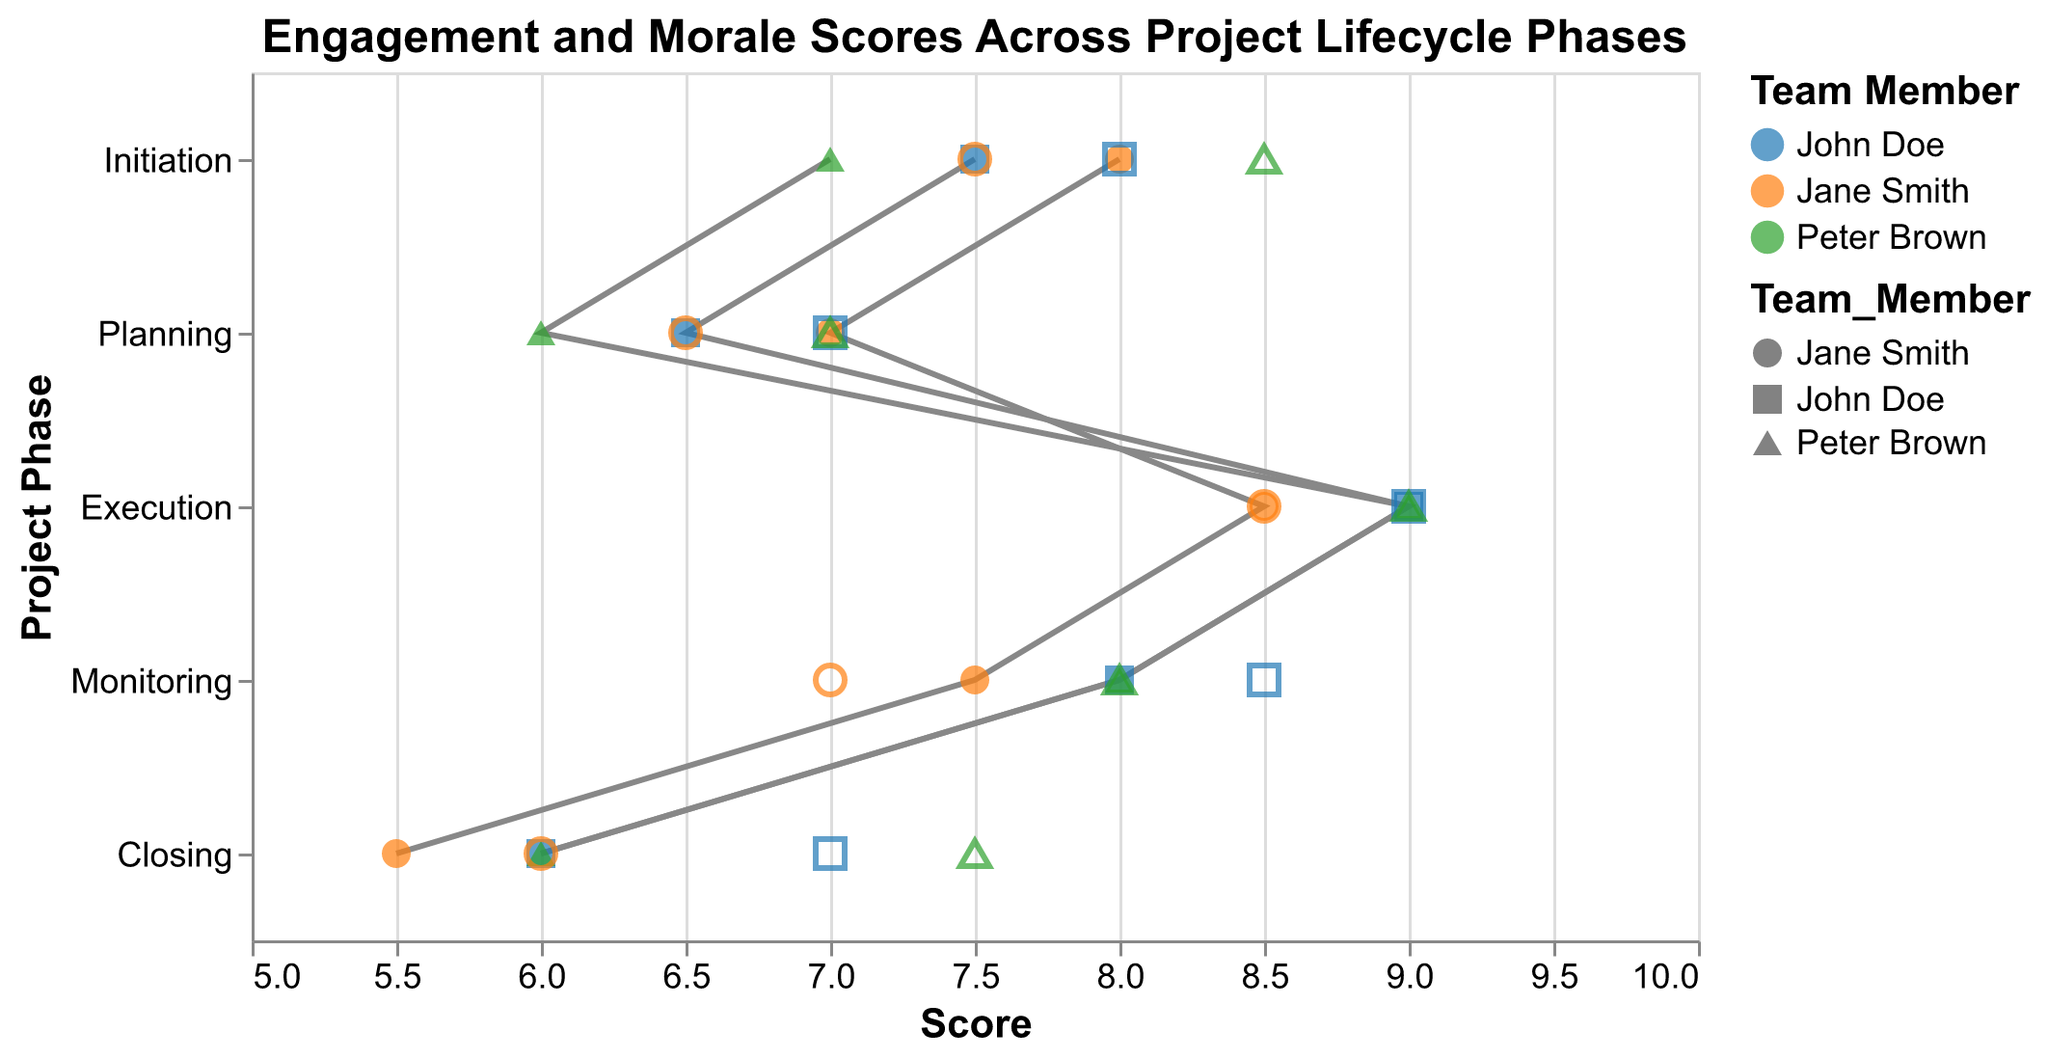What's the title of the figure? The title is always located at the top of the figure. It summarizes the figure's content.
Answer: Engagement and Morale Scores Across Project Lifecycle Phases Which team member has the highest Engagement Score during the Execution phase? Look at the dots corresponding to the Execution phase and identify the team member with the highest score, marked in blue, orange, or green.
Answer: Peter Brown and John Doe What is the average Morale Score during the Initiation phase? The Morale Scores for this phase are 8, 7.5, and 8.5. Sum these values and divide by the number of team members (3). (8 + 7.5 + 8.5) / 3 = 24 / 3
Answer: 8 How does Jane Smith’s Engagement Score change from the Planning to Execution phase? Compare Jane Smith’s Engagement Scores in both phases. In Planning, it is 7, and in Execution, it is 8.5. The change is 8.5 - 7 = 1.5.
Answer: Increases by 1.5 Which project phase shows the lowest Engagement Scores for all three team members? Review the Engagement Scores for each phase and find the phase where all three scores are lower than those in other phases.
Answer: Closing How do Engagement and Morale Scores in the Monitoring phase compare for John Doe? Check John Doe’s scores in the Monitoring phase. His Engagement Score is 8, and his Morale Score is 8.5. Compare them by checking which is higher or if they are equal.
Answer: Morale Score is higher What is the range of Engagement Scores in the Initiation phase? Identify the minimum and maximum Engagement Scores in the Initiation phase. The scores are 7, 7.5, and 8. The range is the difference between the highest and lowest scores. 8 - 7 = 1.
Answer: 1 Which phase shows the most significant difference between Engagement and Morale Scores for Peter Brown? Calculate the differences between Engagement and Morale Scores for Peter Brown in each phase: Initiation (8.5 - 7 = 1.5), Planning (7 - 6 = 1), Execution (9 - 9 = 0), Monitoring (8 - 8 = 0), Closing (7.5 - 6 = 1.5). Compare these differences.
Answer: Initiation and Closing During which phase do all team members have the same Morale Score? Look at each phase’s Morale Scores for all team members. Identify the phase where all displayed Morale Scores are identical.
Answer: Execution What trend can be observed for John Doe’s Engagement Scores from the Initiation to Closing phase? Trace John Doe’s Engagement Scores sequentially across all phases: Initiation (7.5), Planning (6.5), Execution (9), Monitoring (8), Closing (6). Identify if the scores increase, decrease, or show fluctuation.
Answer: Fluctuation 